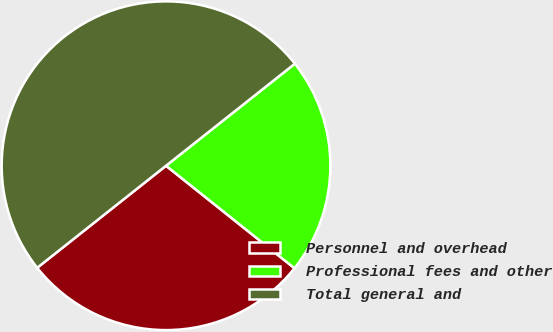Convert chart. <chart><loc_0><loc_0><loc_500><loc_500><pie_chart><fcel>Personnel and overhead<fcel>Professional fees and other<fcel>Total general and<nl><fcel>28.62%<fcel>21.38%<fcel>50.0%<nl></chart> 